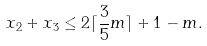<formula> <loc_0><loc_0><loc_500><loc_500>x _ { 2 } + x _ { 3 } \leq 2 \lceil \frac { 3 } { 5 } m \rceil + 1 - m .</formula> 